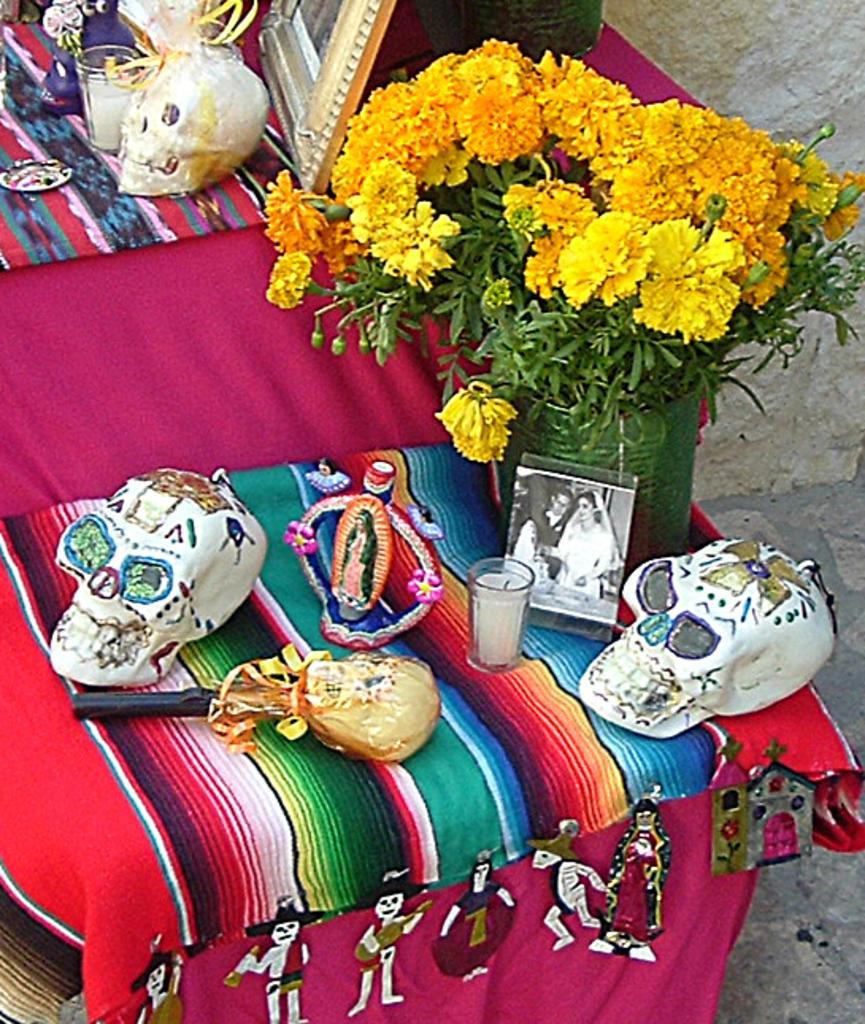How would you summarize this image in a sentence or two? In this image, we can see two white color skulls, there is a photo, there is a green color plant, we can see some yellow color flowers. 